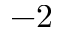<formula> <loc_0><loc_0><loc_500><loc_500>- 2</formula> 